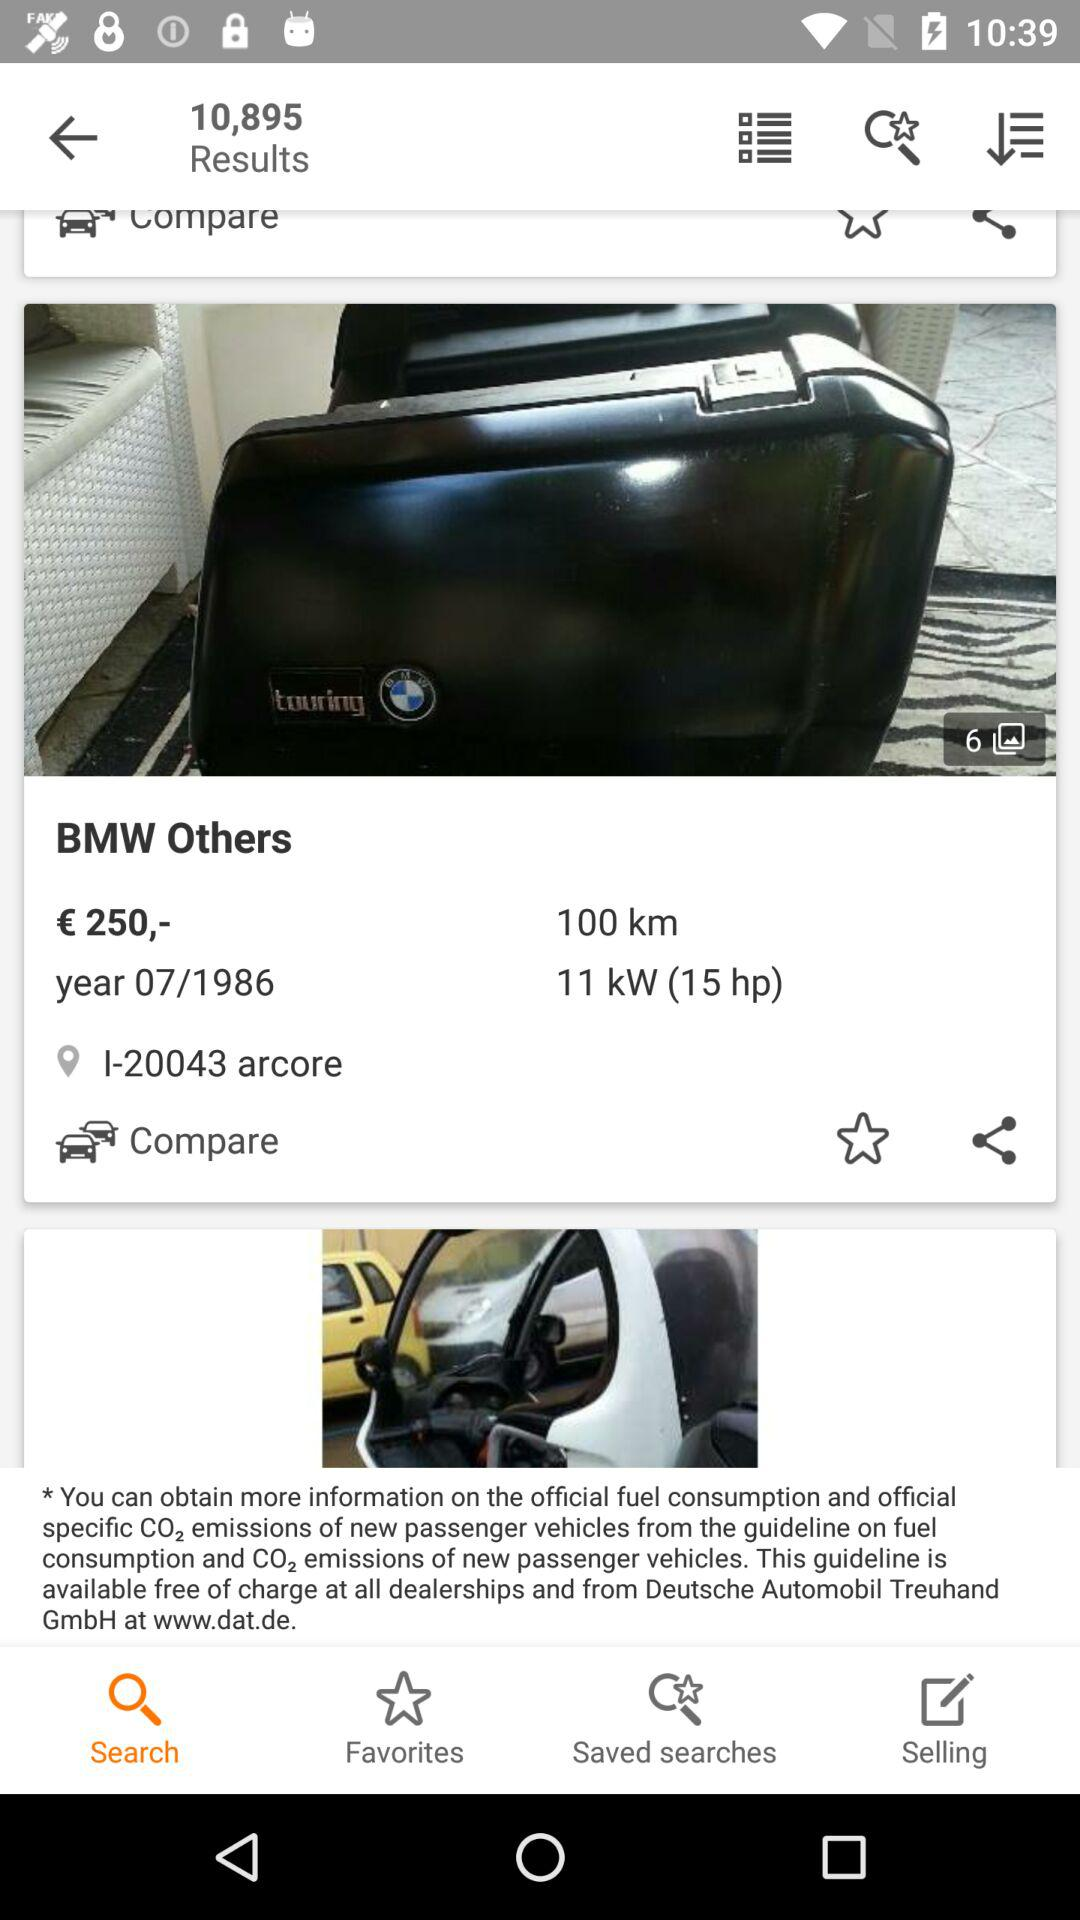What is the power of the engine? The power of the engine is 11 kW (15 hp). 